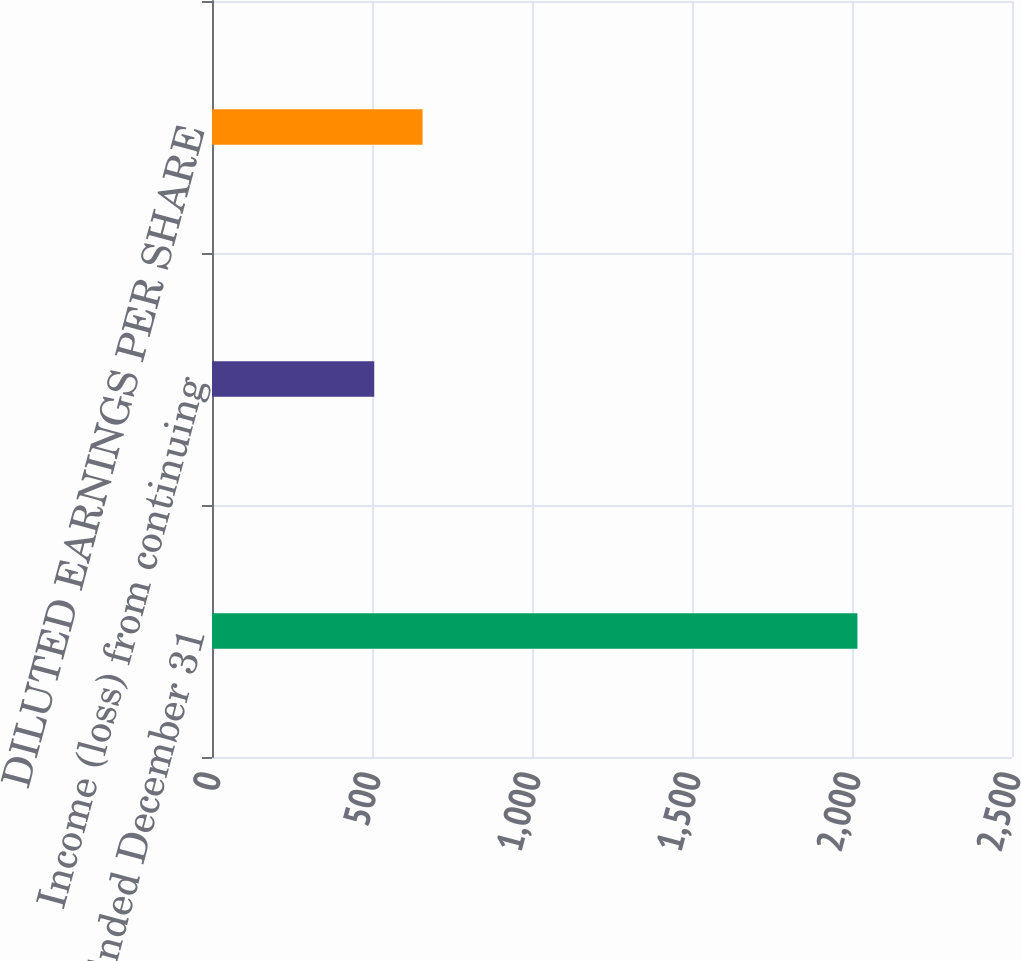<chart> <loc_0><loc_0><loc_500><loc_500><bar_chart><fcel>Year Ended December 31<fcel>Income (loss) from continuing<fcel>DILUTED EARNINGS PER SHARE<nl><fcel>2017<fcel>507<fcel>658<nl></chart> 